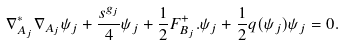Convert formula to latex. <formula><loc_0><loc_0><loc_500><loc_500>\nabla _ { A _ { j } } ^ { * } \nabla _ { A _ { j } } \psi _ { j } + \frac { s ^ { g _ { j } } } 4 \psi _ { j } + \frac { 1 } { 2 } F _ { B _ { j } } ^ { + } . \psi _ { j } + \frac { 1 } { 2 } q ( \psi _ { j } ) \psi _ { j } = 0 .</formula> 